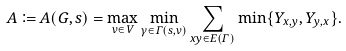Convert formula to latex. <formula><loc_0><loc_0><loc_500><loc_500>A \coloneqq A ( G , s ) = \max _ { v \in V } \min _ { \gamma \in \Gamma ( { s , v } ) } \sum _ { x y \in E ( \Gamma ) } \min \{ Y _ { x , y } , Y _ { y , x } \} .</formula> 